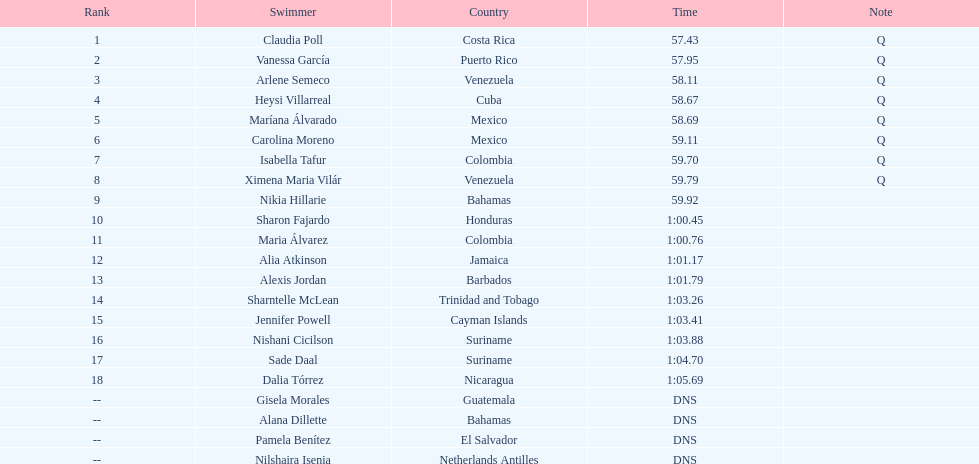How many swimmers had a time of at least 1:00 9. 